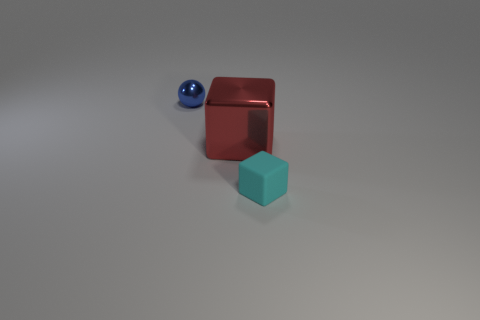Is there anything else that is the same size as the shiny cube?
Give a very brief answer. No. What number of other things are there of the same material as the cyan thing
Your response must be concise. 0. Are there more small cyan blocks than tiny things?
Provide a short and direct response. No. What material is the block that is right of the shiny thing in front of the small thing behind the small cyan block?
Keep it short and to the point. Rubber. There is a cyan matte thing that is the same size as the blue metal sphere; what is its shape?
Keep it short and to the point. Cube. Are there fewer small objects than large red blocks?
Give a very brief answer. No. How many shiny things have the same size as the ball?
Give a very brief answer. 0. What is the large red cube made of?
Provide a short and direct response. Metal. How big is the metal thing behind the big red object?
Provide a succinct answer. Small. How many other cyan things are the same shape as the rubber object?
Offer a terse response. 0. 